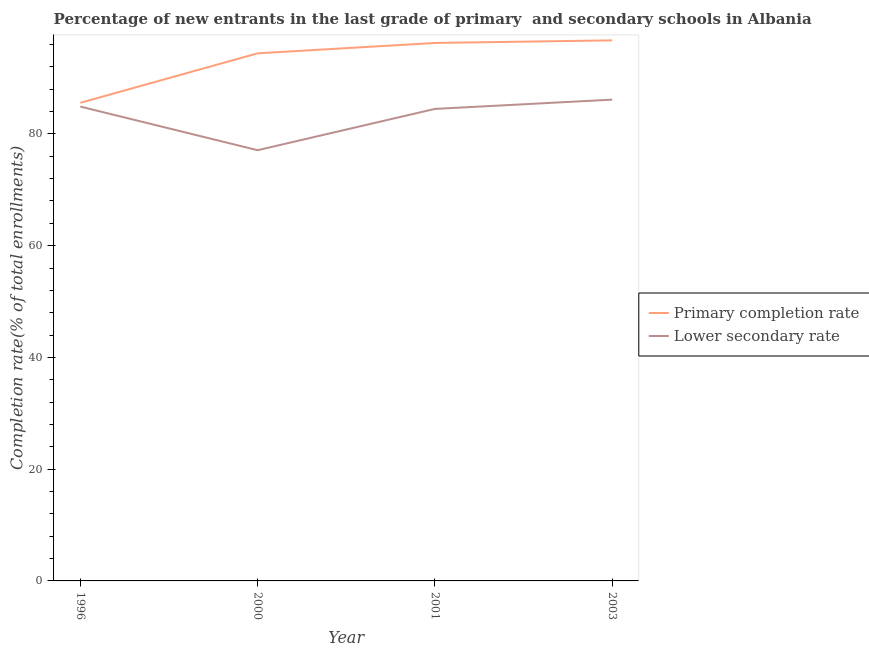How many different coloured lines are there?
Give a very brief answer. 2. Is the number of lines equal to the number of legend labels?
Give a very brief answer. Yes. What is the completion rate in primary schools in 2001?
Provide a short and direct response. 96.29. Across all years, what is the maximum completion rate in secondary schools?
Keep it short and to the point. 86.14. Across all years, what is the minimum completion rate in secondary schools?
Make the answer very short. 77.09. In which year was the completion rate in primary schools minimum?
Ensure brevity in your answer.  1996. What is the total completion rate in secondary schools in the graph?
Keep it short and to the point. 332.61. What is the difference between the completion rate in secondary schools in 1996 and that in 2000?
Offer a terse response. 7.81. What is the difference between the completion rate in primary schools in 1996 and the completion rate in secondary schools in 2000?
Offer a very short reply. 8.48. What is the average completion rate in secondary schools per year?
Offer a very short reply. 83.15. In the year 2003, what is the difference between the completion rate in secondary schools and completion rate in primary schools?
Provide a short and direct response. -10.61. In how many years, is the completion rate in secondary schools greater than 64 %?
Keep it short and to the point. 4. What is the ratio of the completion rate in secondary schools in 1996 to that in 2001?
Ensure brevity in your answer.  1. What is the difference between the highest and the second highest completion rate in primary schools?
Keep it short and to the point. 0.46. What is the difference between the highest and the lowest completion rate in primary schools?
Offer a very short reply. 11.18. In how many years, is the completion rate in secondary schools greater than the average completion rate in secondary schools taken over all years?
Provide a short and direct response. 3. Does the completion rate in secondary schools monotonically increase over the years?
Offer a very short reply. No. Is the completion rate in primary schools strictly less than the completion rate in secondary schools over the years?
Provide a short and direct response. No. How many years are there in the graph?
Give a very brief answer. 4. What is the difference between two consecutive major ticks on the Y-axis?
Your answer should be compact. 20. Does the graph contain grids?
Offer a very short reply. No. What is the title of the graph?
Your answer should be compact. Percentage of new entrants in the last grade of primary  and secondary schools in Albania. What is the label or title of the Y-axis?
Offer a very short reply. Completion rate(% of total enrollments). What is the Completion rate(% of total enrollments) of Primary completion rate in 1996?
Your answer should be compact. 85.57. What is the Completion rate(% of total enrollments) of Lower secondary rate in 1996?
Make the answer very short. 84.9. What is the Completion rate(% of total enrollments) in Primary completion rate in 2000?
Ensure brevity in your answer.  94.43. What is the Completion rate(% of total enrollments) in Lower secondary rate in 2000?
Your response must be concise. 77.09. What is the Completion rate(% of total enrollments) of Primary completion rate in 2001?
Provide a succinct answer. 96.29. What is the Completion rate(% of total enrollments) in Lower secondary rate in 2001?
Your answer should be compact. 84.48. What is the Completion rate(% of total enrollments) in Primary completion rate in 2003?
Provide a succinct answer. 96.75. What is the Completion rate(% of total enrollments) of Lower secondary rate in 2003?
Provide a succinct answer. 86.14. Across all years, what is the maximum Completion rate(% of total enrollments) of Primary completion rate?
Keep it short and to the point. 96.75. Across all years, what is the maximum Completion rate(% of total enrollments) in Lower secondary rate?
Offer a very short reply. 86.14. Across all years, what is the minimum Completion rate(% of total enrollments) in Primary completion rate?
Offer a terse response. 85.57. Across all years, what is the minimum Completion rate(% of total enrollments) in Lower secondary rate?
Your answer should be compact. 77.09. What is the total Completion rate(% of total enrollments) of Primary completion rate in the graph?
Ensure brevity in your answer.  373.03. What is the total Completion rate(% of total enrollments) in Lower secondary rate in the graph?
Your answer should be very brief. 332.61. What is the difference between the Completion rate(% of total enrollments) of Primary completion rate in 1996 and that in 2000?
Your answer should be very brief. -8.86. What is the difference between the Completion rate(% of total enrollments) of Lower secondary rate in 1996 and that in 2000?
Provide a succinct answer. 7.81. What is the difference between the Completion rate(% of total enrollments) of Primary completion rate in 1996 and that in 2001?
Offer a terse response. -10.71. What is the difference between the Completion rate(% of total enrollments) of Lower secondary rate in 1996 and that in 2001?
Your answer should be compact. 0.42. What is the difference between the Completion rate(% of total enrollments) of Primary completion rate in 1996 and that in 2003?
Offer a terse response. -11.18. What is the difference between the Completion rate(% of total enrollments) in Lower secondary rate in 1996 and that in 2003?
Ensure brevity in your answer.  -1.24. What is the difference between the Completion rate(% of total enrollments) in Primary completion rate in 2000 and that in 2001?
Provide a short and direct response. -1.86. What is the difference between the Completion rate(% of total enrollments) in Lower secondary rate in 2000 and that in 2001?
Provide a succinct answer. -7.39. What is the difference between the Completion rate(% of total enrollments) in Primary completion rate in 2000 and that in 2003?
Provide a short and direct response. -2.32. What is the difference between the Completion rate(% of total enrollments) of Lower secondary rate in 2000 and that in 2003?
Your answer should be very brief. -9.05. What is the difference between the Completion rate(% of total enrollments) of Primary completion rate in 2001 and that in 2003?
Offer a terse response. -0.46. What is the difference between the Completion rate(% of total enrollments) in Lower secondary rate in 2001 and that in 2003?
Provide a succinct answer. -1.66. What is the difference between the Completion rate(% of total enrollments) of Primary completion rate in 1996 and the Completion rate(% of total enrollments) of Lower secondary rate in 2000?
Your answer should be very brief. 8.48. What is the difference between the Completion rate(% of total enrollments) in Primary completion rate in 1996 and the Completion rate(% of total enrollments) in Lower secondary rate in 2001?
Your answer should be compact. 1.09. What is the difference between the Completion rate(% of total enrollments) in Primary completion rate in 1996 and the Completion rate(% of total enrollments) in Lower secondary rate in 2003?
Offer a very short reply. -0.57. What is the difference between the Completion rate(% of total enrollments) in Primary completion rate in 2000 and the Completion rate(% of total enrollments) in Lower secondary rate in 2001?
Give a very brief answer. 9.95. What is the difference between the Completion rate(% of total enrollments) in Primary completion rate in 2000 and the Completion rate(% of total enrollments) in Lower secondary rate in 2003?
Your answer should be compact. 8.29. What is the difference between the Completion rate(% of total enrollments) in Primary completion rate in 2001 and the Completion rate(% of total enrollments) in Lower secondary rate in 2003?
Your answer should be very brief. 10.15. What is the average Completion rate(% of total enrollments) of Primary completion rate per year?
Make the answer very short. 93.26. What is the average Completion rate(% of total enrollments) of Lower secondary rate per year?
Give a very brief answer. 83.15. In the year 1996, what is the difference between the Completion rate(% of total enrollments) of Primary completion rate and Completion rate(% of total enrollments) of Lower secondary rate?
Your answer should be very brief. 0.67. In the year 2000, what is the difference between the Completion rate(% of total enrollments) of Primary completion rate and Completion rate(% of total enrollments) of Lower secondary rate?
Your answer should be very brief. 17.34. In the year 2001, what is the difference between the Completion rate(% of total enrollments) of Primary completion rate and Completion rate(% of total enrollments) of Lower secondary rate?
Ensure brevity in your answer.  11.8. In the year 2003, what is the difference between the Completion rate(% of total enrollments) of Primary completion rate and Completion rate(% of total enrollments) of Lower secondary rate?
Keep it short and to the point. 10.61. What is the ratio of the Completion rate(% of total enrollments) in Primary completion rate in 1996 to that in 2000?
Your answer should be compact. 0.91. What is the ratio of the Completion rate(% of total enrollments) in Lower secondary rate in 1996 to that in 2000?
Keep it short and to the point. 1.1. What is the ratio of the Completion rate(% of total enrollments) of Primary completion rate in 1996 to that in 2001?
Your answer should be compact. 0.89. What is the ratio of the Completion rate(% of total enrollments) in Lower secondary rate in 1996 to that in 2001?
Ensure brevity in your answer.  1. What is the ratio of the Completion rate(% of total enrollments) in Primary completion rate in 1996 to that in 2003?
Your answer should be compact. 0.88. What is the ratio of the Completion rate(% of total enrollments) in Lower secondary rate in 1996 to that in 2003?
Make the answer very short. 0.99. What is the ratio of the Completion rate(% of total enrollments) of Primary completion rate in 2000 to that in 2001?
Make the answer very short. 0.98. What is the ratio of the Completion rate(% of total enrollments) in Lower secondary rate in 2000 to that in 2001?
Give a very brief answer. 0.91. What is the ratio of the Completion rate(% of total enrollments) in Primary completion rate in 2000 to that in 2003?
Offer a terse response. 0.98. What is the ratio of the Completion rate(% of total enrollments) in Lower secondary rate in 2000 to that in 2003?
Your answer should be compact. 0.89. What is the ratio of the Completion rate(% of total enrollments) of Primary completion rate in 2001 to that in 2003?
Make the answer very short. 1. What is the ratio of the Completion rate(% of total enrollments) of Lower secondary rate in 2001 to that in 2003?
Keep it short and to the point. 0.98. What is the difference between the highest and the second highest Completion rate(% of total enrollments) in Primary completion rate?
Ensure brevity in your answer.  0.46. What is the difference between the highest and the second highest Completion rate(% of total enrollments) of Lower secondary rate?
Offer a terse response. 1.24. What is the difference between the highest and the lowest Completion rate(% of total enrollments) in Primary completion rate?
Ensure brevity in your answer.  11.18. What is the difference between the highest and the lowest Completion rate(% of total enrollments) of Lower secondary rate?
Make the answer very short. 9.05. 